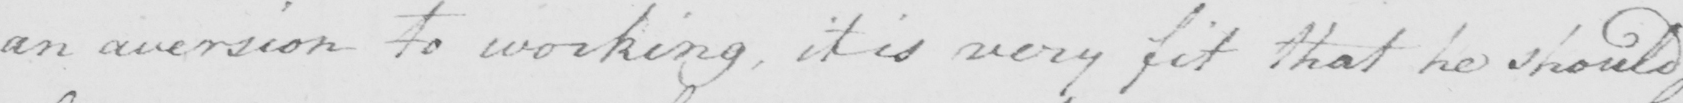Can you tell me what this handwritten text says? an aversion to working , it is very fit that he should 